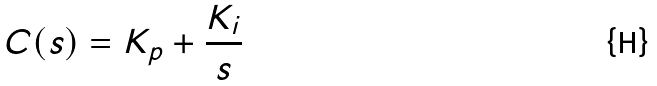<formula> <loc_0><loc_0><loc_500><loc_500>C ( s ) = K _ { p } + \frac { K _ { i } } { s } \</formula> 